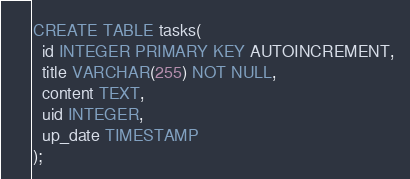<code> <loc_0><loc_0><loc_500><loc_500><_SQL_>CREATE TABLE tasks(
  id INTEGER PRIMARY KEY AUTOINCREMENT,
  title VARCHAR(255) NOT NULL,
  content TEXT,
  uid INTEGER,
  up_date TIMESTAMP
);</code> 